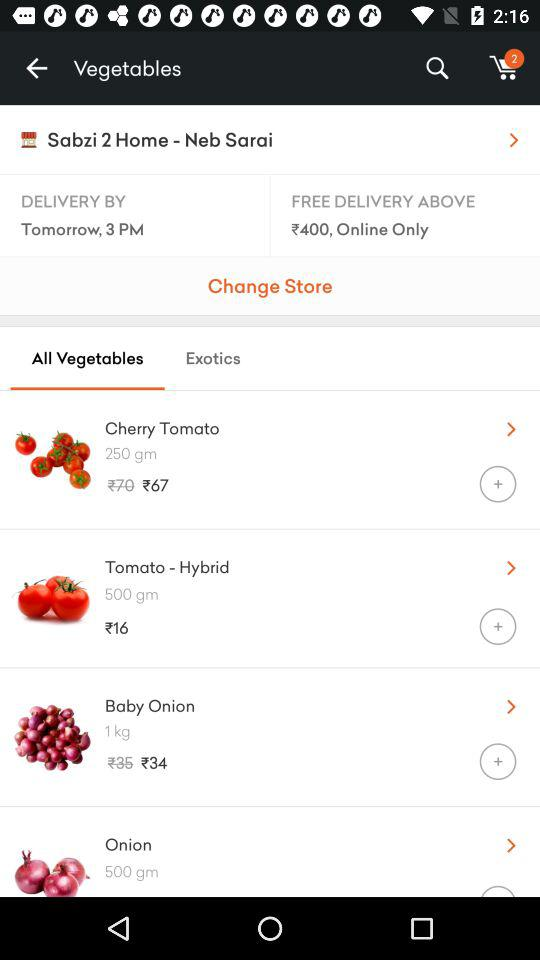How much does 500 grams of "Tomato - Hybrid" cost? "Tomato - Hybrid" costs ₹16. 